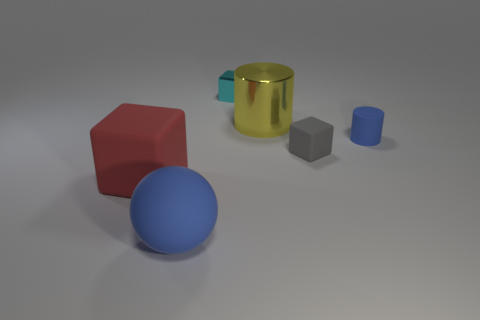What is the big yellow object made of?
Keep it short and to the point. Metal. What color is the matte object in front of the big red cube?
Offer a very short reply. Blue. Are there more metal blocks that are behind the small blue matte object than large red blocks that are behind the cyan cube?
Offer a very short reply. Yes. How big is the metallic object in front of the small metallic cube that is behind the blue thing on the left side of the small gray matte thing?
Provide a succinct answer. Large. Are there any tiny matte things that have the same color as the matte sphere?
Ensure brevity in your answer.  Yes. What number of red objects are there?
Give a very brief answer. 1. There is a large thing right of the blue sphere in front of the blue rubber thing on the right side of the big blue thing; what is its material?
Offer a terse response. Metal. Is there a small cyan object made of the same material as the large yellow cylinder?
Your response must be concise. Yes. Is the cyan thing made of the same material as the yellow cylinder?
Your response must be concise. Yes. How many cubes are either large red objects or metal things?
Your answer should be very brief. 2. 